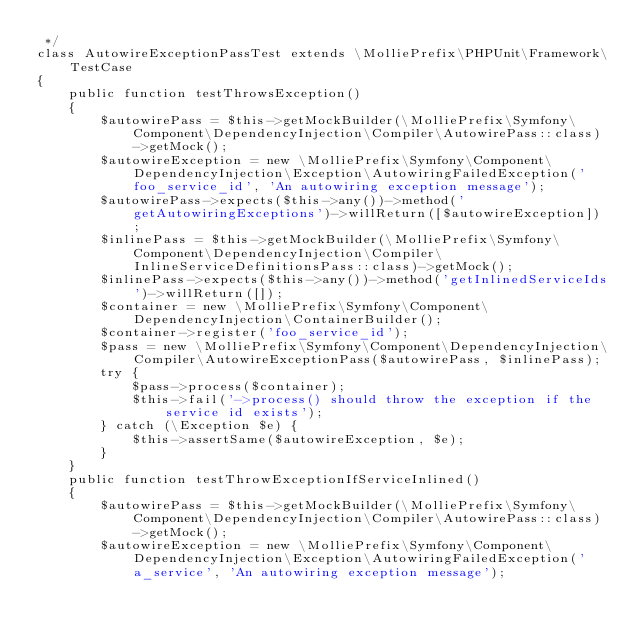<code> <loc_0><loc_0><loc_500><loc_500><_PHP_> */
class AutowireExceptionPassTest extends \MolliePrefix\PHPUnit\Framework\TestCase
{
    public function testThrowsException()
    {
        $autowirePass = $this->getMockBuilder(\MolliePrefix\Symfony\Component\DependencyInjection\Compiler\AutowirePass::class)->getMock();
        $autowireException = new \MolliePrefix\Symfony\Component\DependencyInjection\Exception\AutowiringFailedException('foo_service_id', 'An autowiring exception message');
        $autowirePass->expects($this->any())->method('getAutowiringExceptions')->willReturn([$autowireException]);
        $inlinePass = $this->getMockBuilder(\MolliePrefix\Symfony\Component\DependencyInjection\Compiler\InlineServiceDefinitionsPass::class)->getMock();
        $inlinePass->expects($this->any())->method('getInlinedServiceIds')->willReturn([]);
        $container = new \MolliePrefix\Symfony\Component\DependencyInjection\ContainerBuilder();
        $container->register('foo_service_id');
        $pass = new \MolliePrefix\Symfony\Component\DependencyInjection\Compiler\AutowireExceptionPass($autowirePass, $inlinePass);
        try {
            $pass->process($container);
            $this->fail('->process() should throw the exception if the service id exists');
        } catch (\Exception $e) {
            $this->assertSame($autowireException, $e);
        }
    }
    public function testThrowExceptionIfServiceInlined()
    {
        $autowirePass = $this->getMockBuilder(\MolliePrefix\Symfony\Component\DependencyInjection\Compiler\AutowirePass::class)->getMock();
        $autowireException = new \MolliePrefix\Symfony\Component\DependencyInjection\Exception\AutowiringFailedException('a_service', 'An autowiring exception message');</code> 